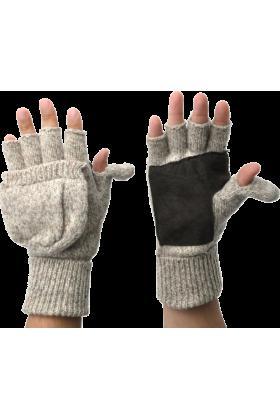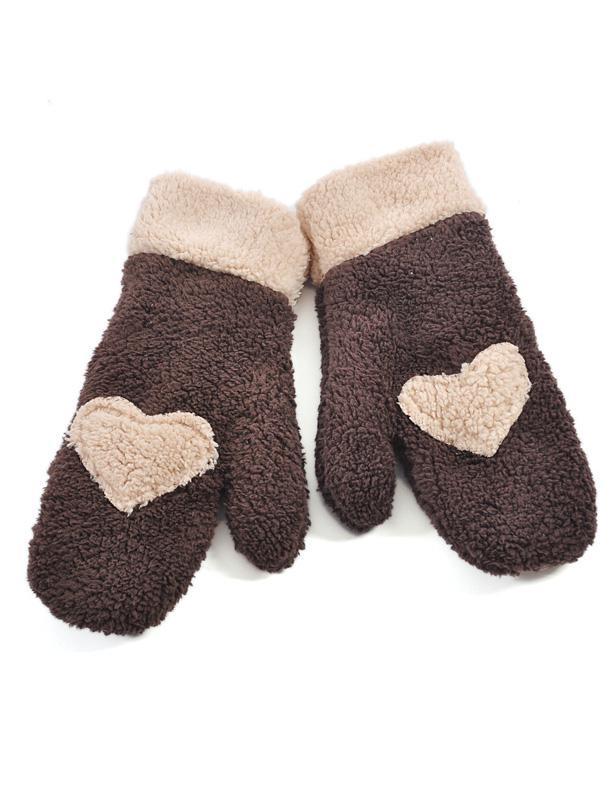The first image is the image on the left, the second image is the image on the right. For the images shown, is this caption "One of the pairs of mittens is the open-fingered style." true? Answer yes or no. Yes. The first image is the image on the left, the second image is the image on the right. Considering the images on both sides, is "Some of the mittens or gloves are furry and none of them are being worn." valid? Answer yes or no. No. 